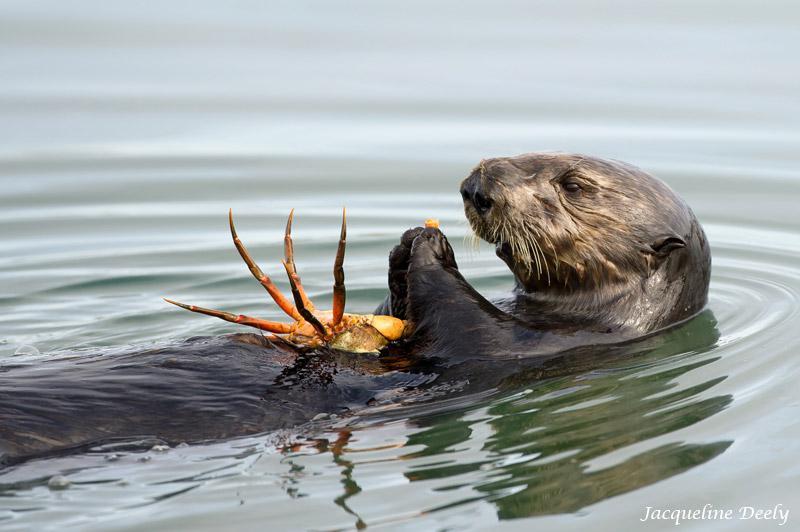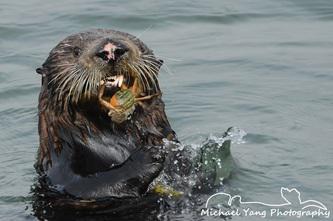The first image is the image on the left, the second image is the image on the right. Examine the images to the left and right. Is the description "There are two otters which each have a crab in their mouth." accurate? Answer yes or no. No. The first image is the image on the left, the second image is the image on the right. Analyze the images presented: Is the assertion "In at least one image there is a floating seal with crab in his mouth." valid? Answer yes or no. No. 